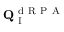<formula> <loc_0><loc_0><loc_500><loc_500>Q _ { I } ^ { d R P A }</formula> 